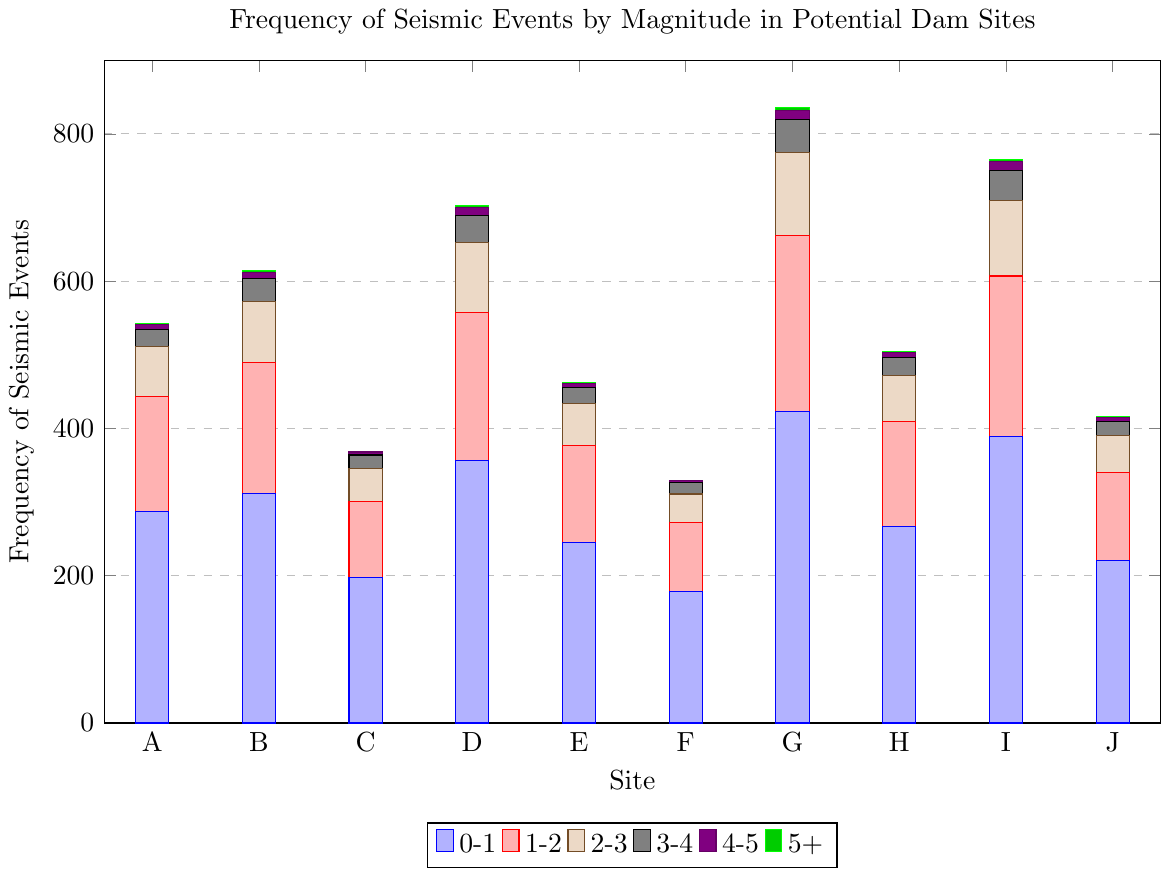What is the total frequency of seismic events for Site G? Add the frequencies for each magnitude category at Site G: 423 + 239 + 113 + 44 + 13 + 4 = 836
Answer: 836 Which site has the highest frequency of seismic events in the 3-4 magnitude range? Compare the 3-4 magnitude frequencies across all sites: Site A (23), Site B (31), Site C (18), Site D (37), Site E (21), Site F (15), Site G (44), Site H (24), Site I (40), Site J (19). Site G has the highest frequency of 44.
Answer: Site G Which site has the fewest seismic events in the 0-1 magnitude range? Compare the 0-1 magnitude frequencies across all sites: Site A (287), Site B (312), Site C (198), Site D (356), Site E (245), Site F (178), Site G (423), Site H (267), Site I (389), Site J (221). Site F has the fewest frequency with 178.
Answer: Site F What is the difference in the total number of seismic events between Site A and Site B? Calculate the difference: total events in Site A (287+156+68+23+7+1 = 542) and Site B (312+178+82+31+9+2 = 614); then, 614 - 542 = 72
Answer: 72 How many total seismic events in the 4-5 magnitude category occurred across all sites? Sum the frequencies in the 4-5 magnitude category for all sites: 7 + 9 + 4 + 11 + 6 + 3 + 13 + 7 + 12 + 5 = 77
Answer: 77 Which site has the largest range of seismic event frequencies across all magnitudes? Calculate the range by subtracting the minimum from the maximum frequency for each site: Site A (287-1 = 286), Site B (312-2 = 310), Site C (198-0 = 198), Site D (356-3 = 353), Site E (245-1 = 244), Site F (178-0 = 178), Site G (423-4 = 419), Site H (267-1 = 266), Site I (389-3 = 386), Site J (221-1 = 220). Site G has the largest range of 419.
Answer: Site G What is the average frequency of 2-3 magnitude events across all sites? Calculate the sum of 2-3 magnitude frequencies and divide by the number of sites: (68 + 82 + 45 + 95 + 57 + 39 + 113 + 62 + 103 + 51) / 10 = 715 / 10 = 71.5
Answer: 71.5 What is the total frequency of seismic events for Site E in magnitudes greater than 3? Add the frequencies for magnitudes greater than 3 at Site E: 21 (3-4) + 6 (4-5) + 1 (5+) = 28
Answer: 28 Compare the number of seismic events of magnitude 1-2 between Site D and Site H. How much more does one have than the other? Magnitude 1-2 frequency for Site D is 201, for Site H is 143. The difference is 201 - 143 = 58
Answer: 58 